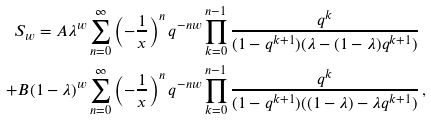Convert formula to latex. <formula><loc_0><loc_0><loc_500><loc_500>S _ { w } = A \lambda ^ { w } & \sum _ { n = 0 } ^ { \infty } \left ( - \frac { 1 } { x } \right ) ^ { n } q ^ { - n w } \prod _ { k = 0 } ^ { n - 1 } \frac { q ^ { k } } { ( 1 - q ^ { k + 1 } ) ( \lambda - ( 1 - \lambda ) q ^ { k + 1 } ) } \\ + B ( 1 - \lambda ) ^ { w } & \sum _ { n = 0 } ^ { \infty } \left ( - \frac { 1 } { x } \right ) ^ { n } q ^ { - n w } \prod _ { k = 0 } ^ { n - 1 } \frac { q ^ { k } } { ( 1 - q ^ { k + 1 } ) ( ( 1 - \lambda ) - \lambda q ^ { k + 1 } ) } \, ,</formula> 